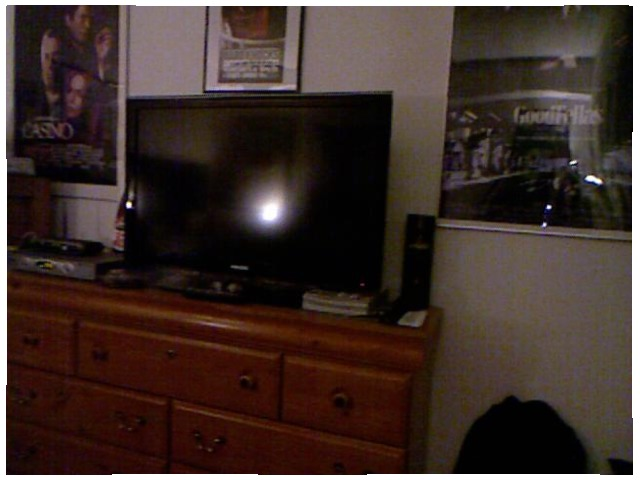<image>
Can you confirm if the knob is on the drawer? Yes. Looking at the image, I can see the knob is positioned on top of the drawer, with the drawer providing support. Where is the tv in relation to the dresser? Is it on the dresser? Yes. Looking at the image, I can see the tv is positioned on top of the dresser, with the dresser providing support. Is there a television on the wall? No. The television is not positioned on the wall. They may be near each other, but the television is not supported by or resting on top of the wall. Is there a table behind the television? No. The table is not behind the television. From this viewpoint, the table appears to be positioned elsewhere in the scene. Where is the tv in relation to the dresser? Is it under the dresser? No. The tv is not positioned under the dresser. The vertical relationship between these objects is different. 